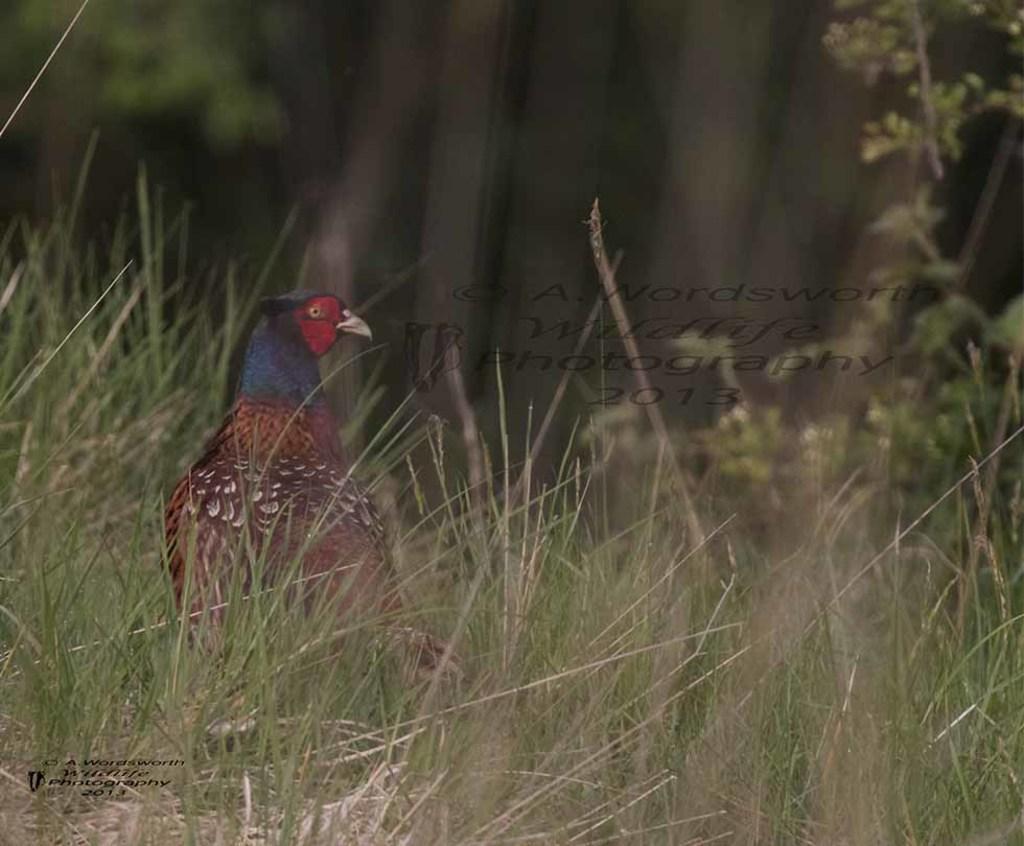Describe this image in one or two sentences. In this image I can see the grass. I can see a bird. In the background, I can see the trees. 